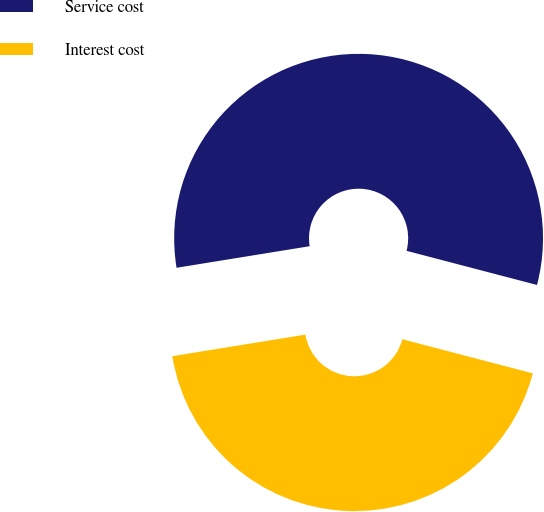Convert chart. <chart><loc_0><loc_0><loc_500><loc_500><pie_chart><fcel>Service cost<fcel>Interest cost<nl><fcel>56.63%<fcel>43.37%<nl></chart> 